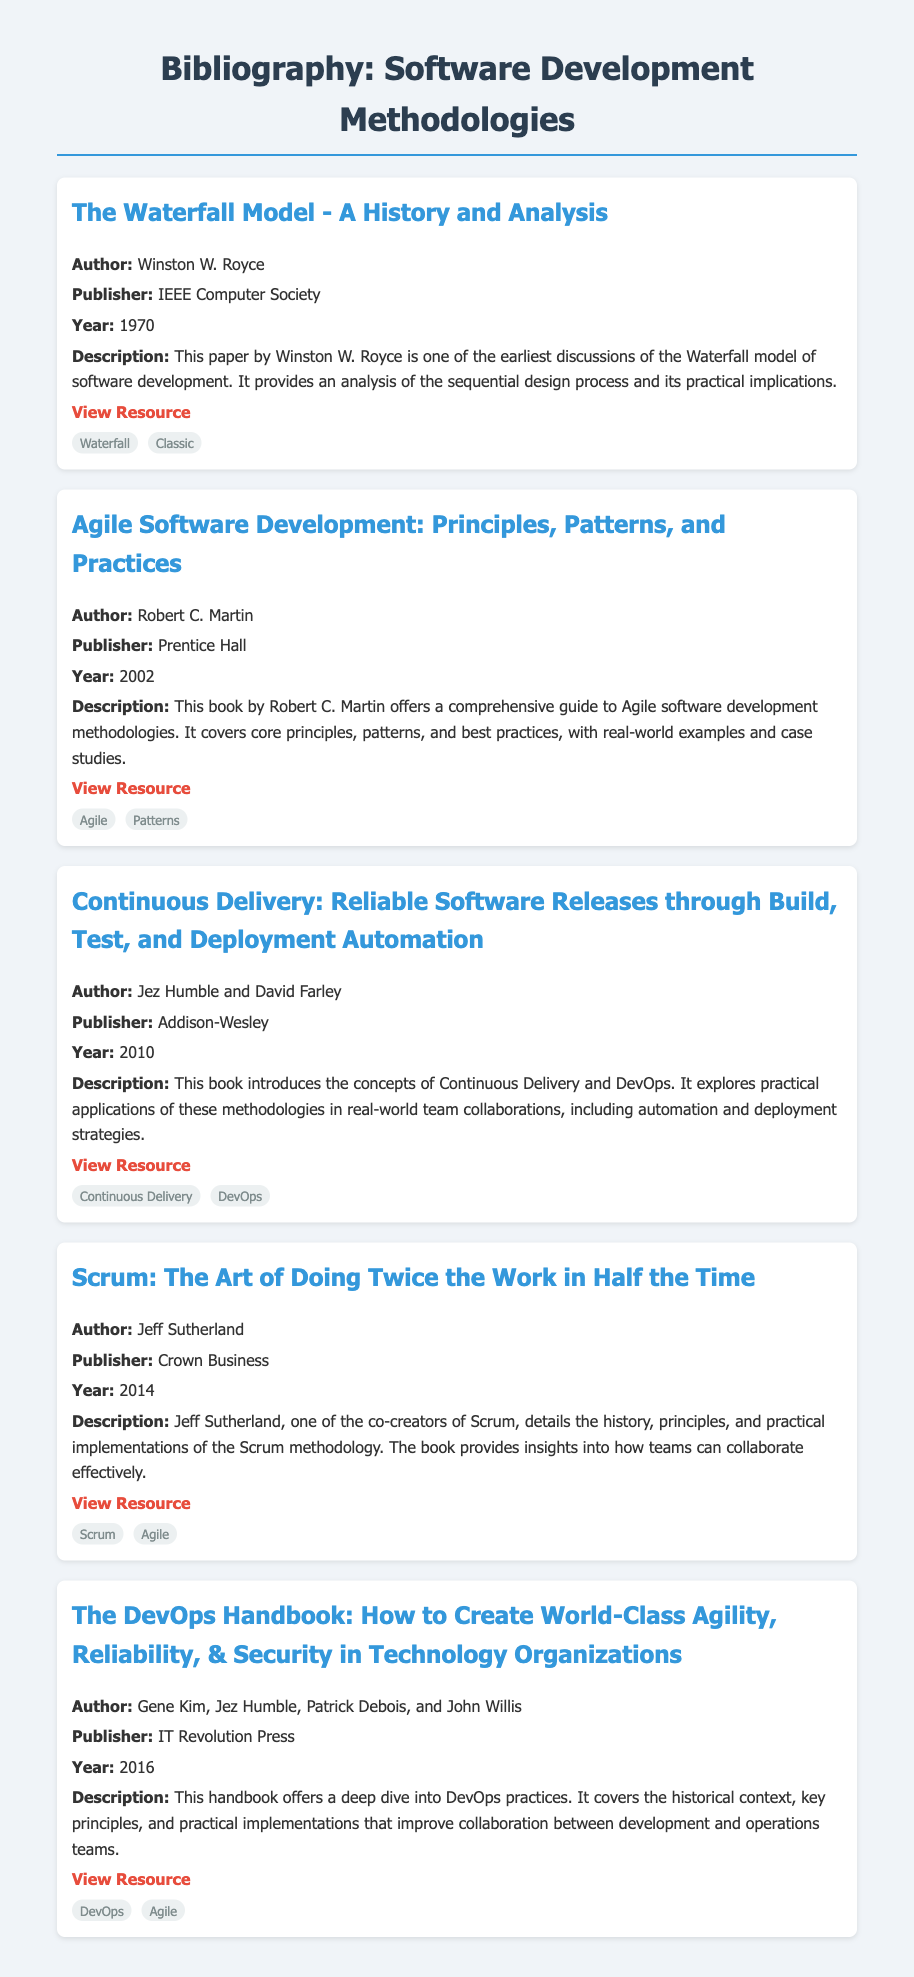What is the title of the first item? The title can be found at the top of the bibliography item describing the Waterfall Model.
Answer: The Waterfall Model - A History and Analysis Who is the author of the book about Agile software development? The author's name is specified in the bibliography for the Agile book.
Answer: Robert C. Martin What year was "Continuous Delivery" published? The year of publication is clearly stated in the second bibliography item's details.
Answer: 2010 What methodology is discussed in Jeff Sutherland's book? The methodology is identified as part of the title and description in the corresponding bibliography item.
Answer: Scrum Which publisher released "The DevOps Handbook"? The publisher's name is provided in the description of the DevOps handbook bibliography item.
Answer: IT Revolution Press How many tags are listed for the book on Continuous Delivery? The number of tags can be counted from the tags displayed below the Continuous Delivery bibliography item.
Answer: 2 What is one key focus of the book "Agile Software Development"? The focus can be inferred from the description provided in the bibliography item for this book.
Answer: Principles What is the main topic of Winston W. Royce's paper? The topic can be identified from the title and description of the first bibliography item.
Answer: Waterfall model Who are the authors of "Continuous Delivery"? The authors' names are listed at the beginning of the corresponding bibliography item.
Answer: Jez Humble and David Farley 